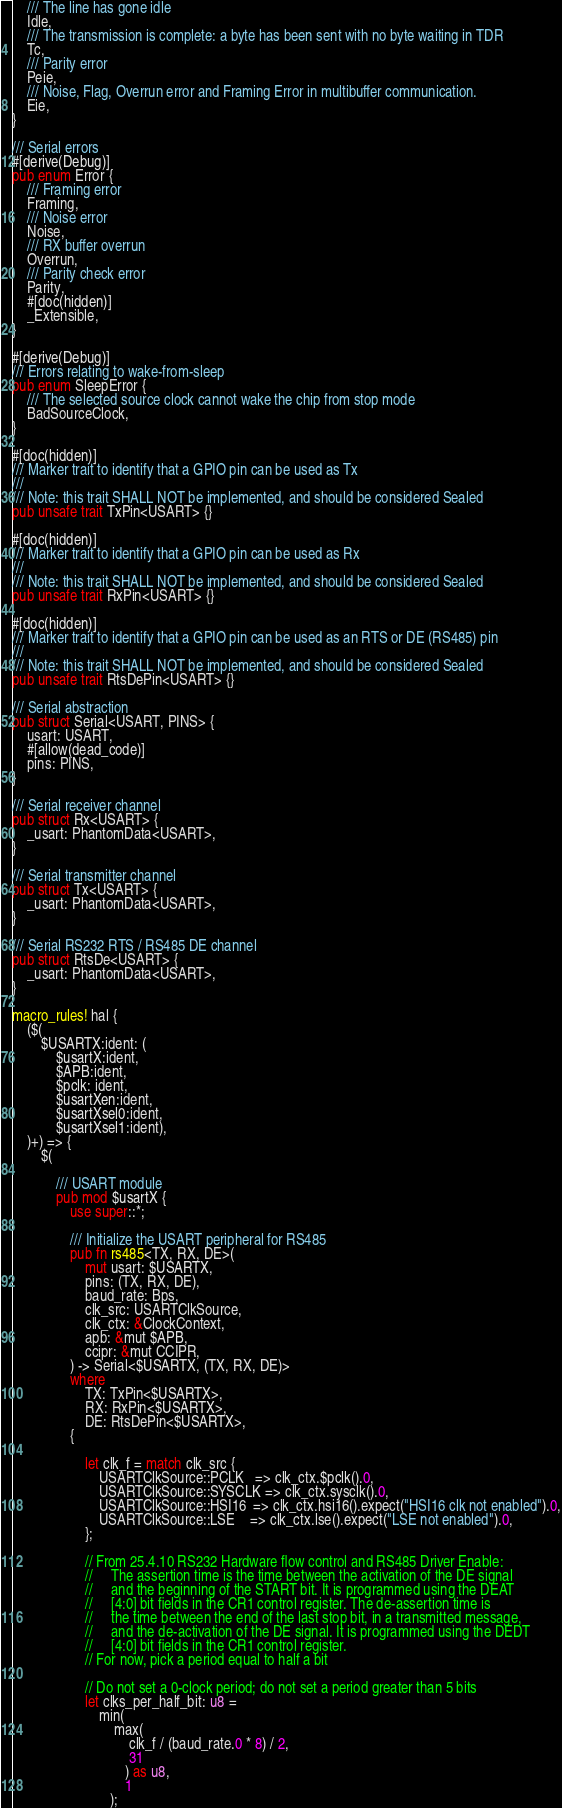Convert code to text. <code><loc_0><loc_0><loc_500><loc_500><_Rust_>    /// The line has gone idle
    Idle,
    /// The transmission is complete: a byte has been sent with no byte waiting in TDR
    Tc,
    /// Parity error
    Peie,
    /// Noise, Flag, Overrun error and Framing Error in multibuffer communication.
    Eie,
}

/// Serial errors
#[derive(Debug)]
pub enum Error {
    /// Framing error
    Framing,
    /// Noise error
    Noise,
    /// RX buffer overrun
    Overrun,
    /// Parity check error
    Parity,
    #[doc(hidden)]
    _Extensible,
}

#[derive(Debug)]
/// Errors relating to wake-from-sleep
pub enum SleepError {
    /// The selected source clock cannot wake the chip from stop mode
    BadSourceClock,
}

#[doc(hidden)]
/// Marker trait to identify that a GPIO pin can be used as Tx
///
/// Note: this trait SHALL NOT be implemented, and should be considered Sealed
pub unsafe trait TxPin<USART> {}

#[doc(hidden)]
/// Marker trait to identify that a GPIO pin can be used as Rx
///
/// Note: this trait SHALL NOT be implemented, and should be considered Sealed
pub unsafe trait RxPin<USART> {}

#[doc(hidden)]
/// Marker trait to identify that a GPIO pin can be used as an RTS or DE (RS485) pin
///
/// Note: this trait SHALL NOT be implemented, and should be considered Sealed
pub unsafe trait RtsDePin<USART> {}

/// Serial abstraction
pub struct Serial<USART, PINS> {
    usart: USART,
    #[allow(dead_code)]
    pins: PINS,
}

/// Serial receiver channel
pub struct Rx<USART> {
    _usart: PhantomData<USART>,
}

/// Serial transmitter channel
pub struct Tx<USART> {
    _usart: PhantomData<USART>,
}

/// Serial RS232 RTS / RS485 DE channel
pub struct RtsDe<USART> {
    _usart: PhantomData<USART>,
}

macro_rules! hal {
    ($(
        $USARTX:ident: (
            $usartX:ident,
            $APB:ident,
            $pclk: ident,
            $usartXen:ident,
            $usartXsel0:ident,
            $usartXsel1:ident),
    )+) => {
        $(

            /// USART module
            pub mod $usartX {
                use super::*;

                /// Initialize the USART peripheral for RS485
                pub fn rs485<TX, RX, DE>(
                    mut usart: $USARTX,
                    pins: (TX, RX, DE),
                    baud_rate: Bps,
                    clk_src: USARTClkSource,
                    clk_ctx: &ClockContext,
                    apb: &mut $APB,
                    ccipr: &mut CCIPR,
                ) -> Serial<$USARTX, (TX, RX, DE)>
                where
                    TX: TxPin<$USARTX>,
                    RX: RxPin<$USARTX>,
                    DE: RtsDePin<$USARTX>,
                {

                    let clk_f = match clk_src {
                        USARTClkSource::PCLK   => clk_ctx.$pclk().0,
                        USARTClkSource::SYSCLK => clk_ctx.sysclk().0,
                        USARTClkSource::HSI16  => clk_ctx.hsi16().expect("HSI16 clk not enabled").0,
                        USARTClkSource::LSE    => clk_ctx.lse().expect("LSE not enabled").0,
                    };

                    // From 25.4.10 RS232 Hardware flow control and RS485 Driver Enable:
                    //     The assertion time is the time between the activation of the DE signal
                    //     and the beginning of the START bit. It is programmed using the DEAT
                    //     [4:0] bit fields in the CR1 control register. The de-assertion time is
                    //     the time between the end of the last stop bit, in a transmitted message,
                    //     and the de-activation of the DE signal. It is programmed using the DEDT
                    //     [4:0] bit fields in the CR1 control register.
                    // For now, pick a period equal to half a bit

                    // Do not set a 0-clock period; do not set a period greater than 5 bits
                    let clks_per_half_bit: u8 =
                        min(
                            max(
                                clk_f / (baud_rate.0 * 8) / 2,
                                31
                               ) as u8,
                               1
                           );
</code> 